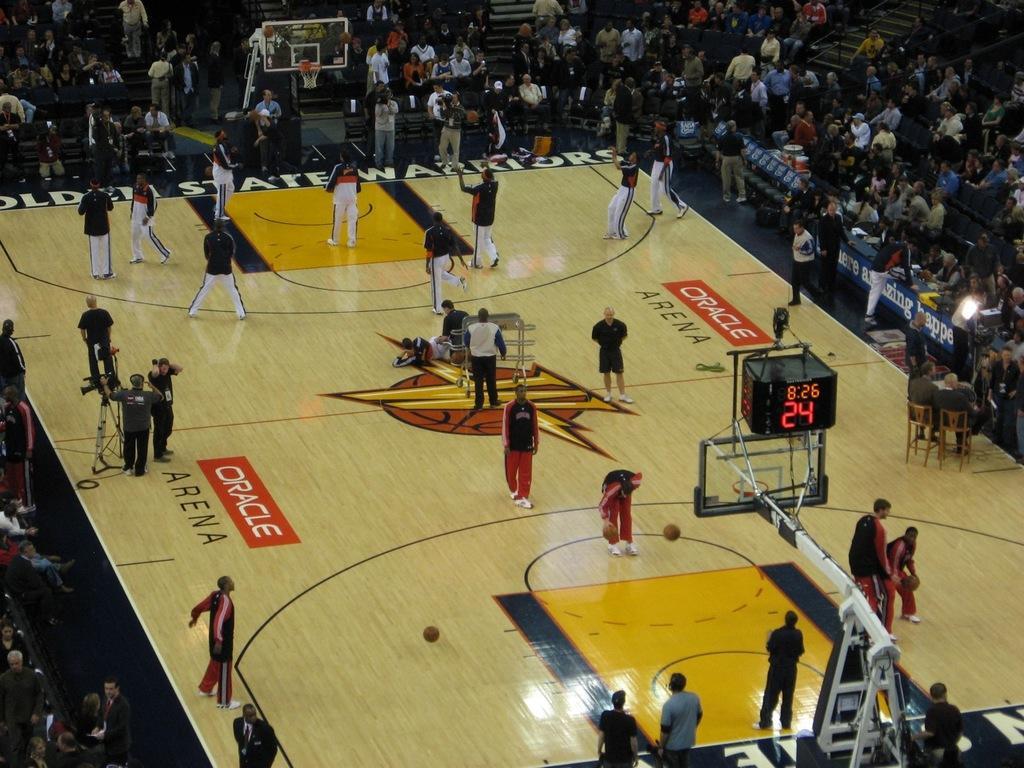Describe this image in one or two sentences. This picture is clicked inside the stadium. In the foreground we can see a basket attached to the metal stand and we can see the group of people standing on the ground and seems to be playing basketball. On the right we can see the group of people and we can see the picture and some text on the ground. In the background we can see the stairs, group of people, tables and many other items. 